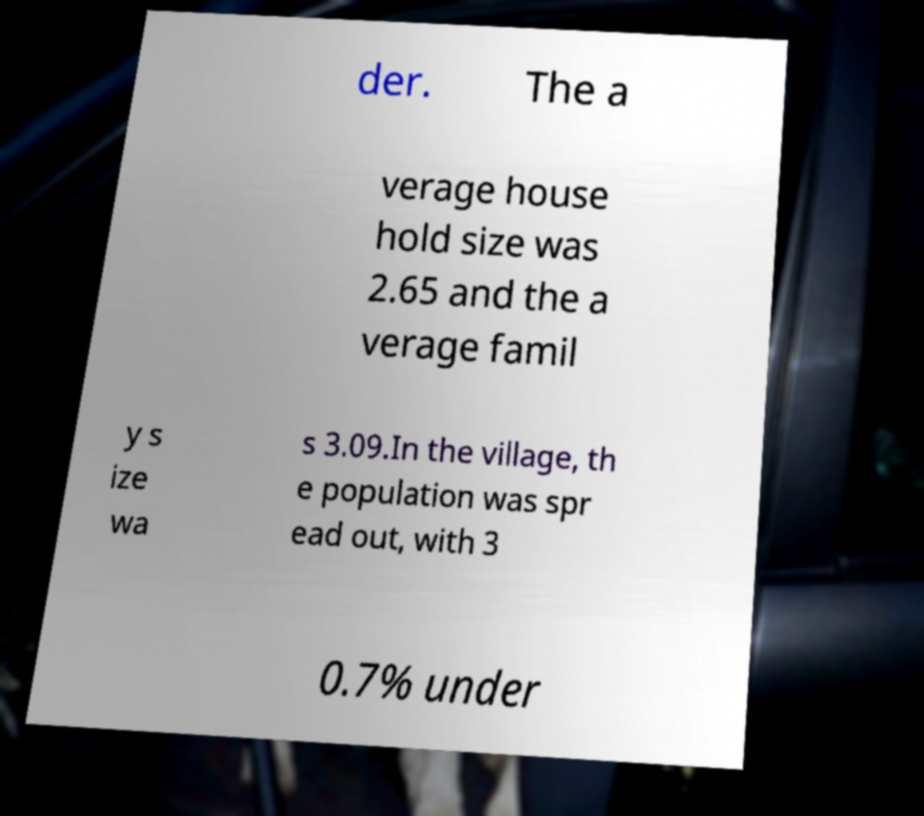Please identify and transcribe the text found in this image. der. The a verage house hold size was 2.65 and the a verage famil y s ize wa s 3.09.In the village, th e population was spr ead out, with 3 0.7% under 